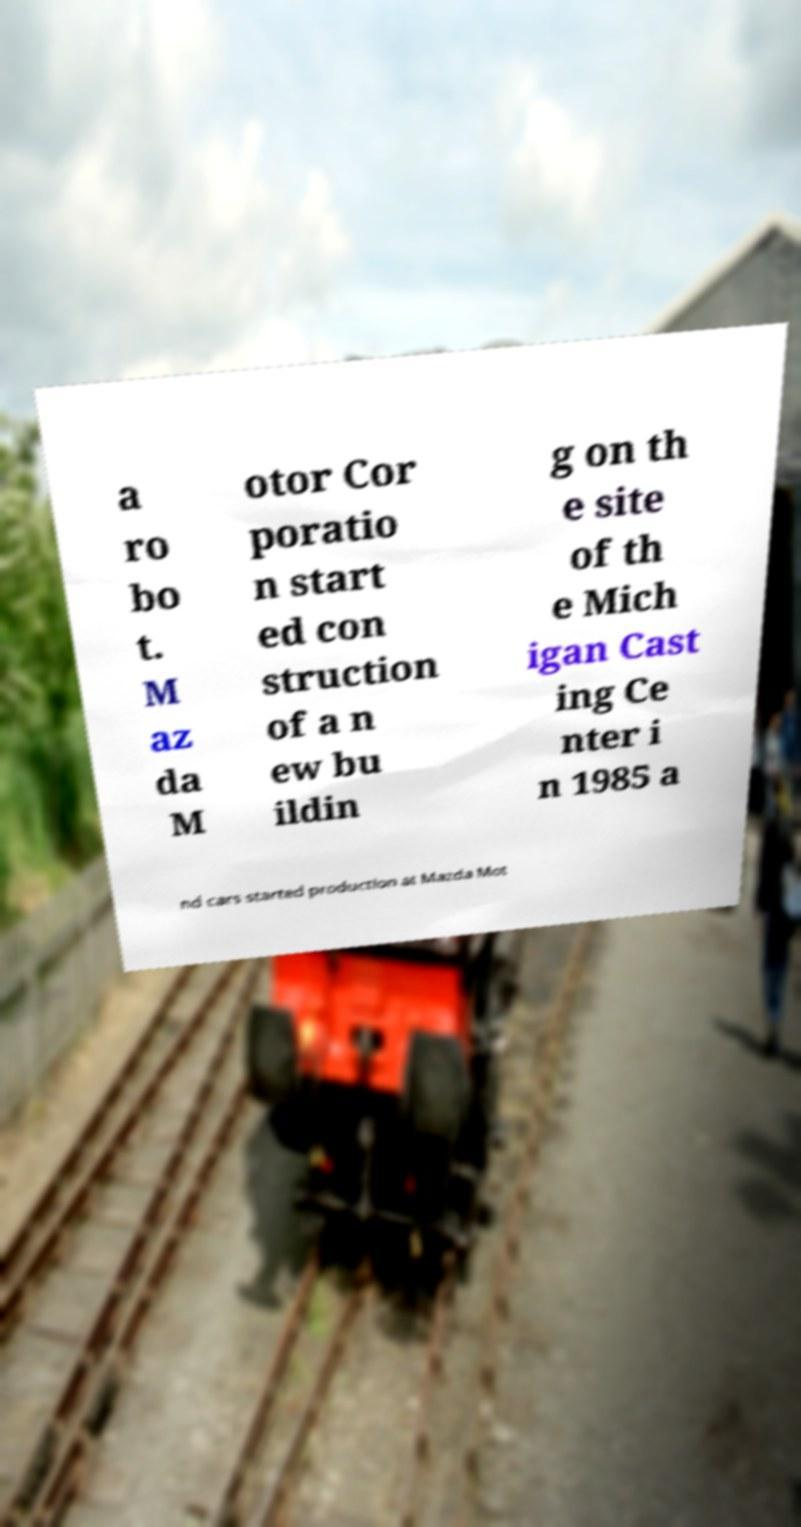There's text embedded in this image that I need extracted. Can you transcribe it verbatim? a ro bo t. M az da M otor Cor poratio n start ed con struction of a n ew bu ildin g on th e site of th e Mich igan Cast ing Ce nter i n 1985 a nd cars started production at Mazda Mot 